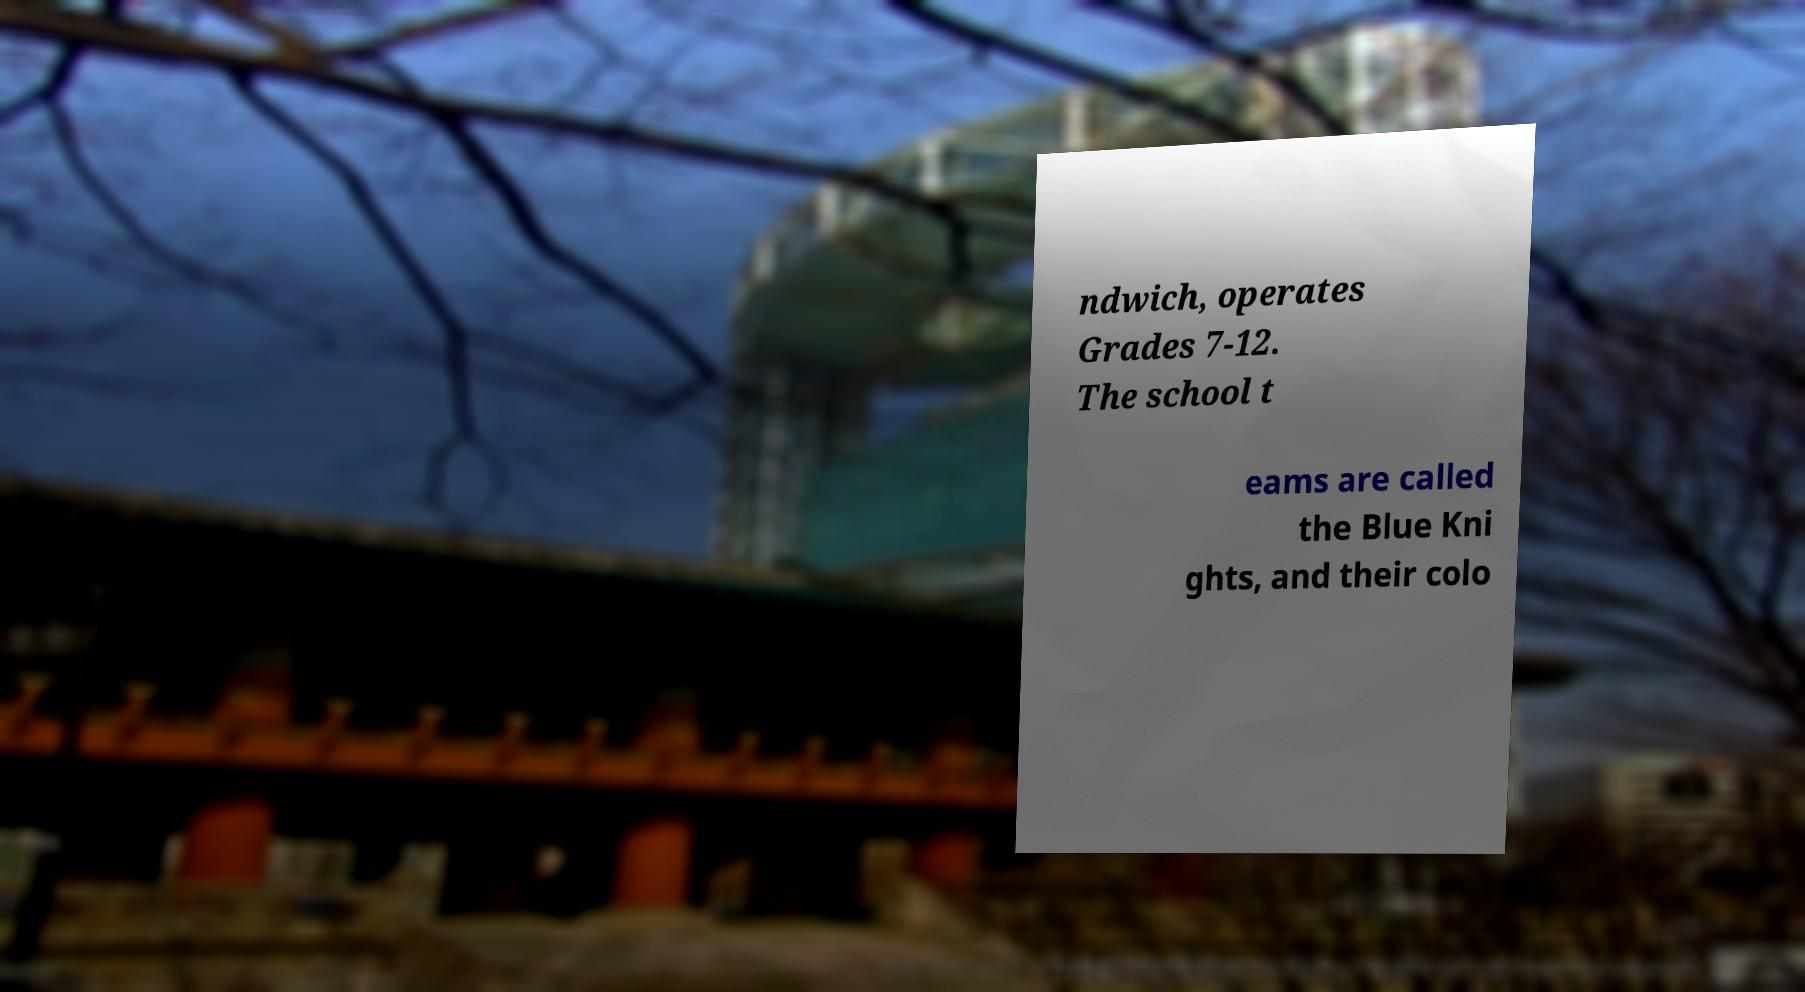Could you extract and type out the text from this image? ndwich, operates Grades 7-12. The school t eams are called the Blue Kni ghts, and their colo 